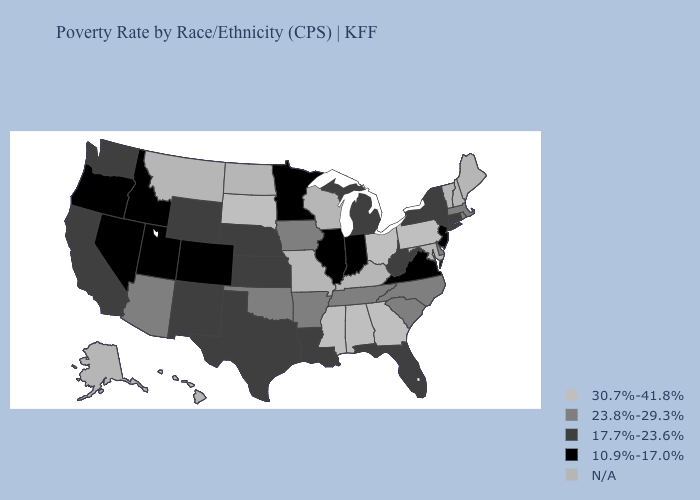Name the states that have a value in the range 23.8%-29.3%?
Short answer required. Arizona, Arkansas, Delaware, Iowa, Massachusetts, North Carolina, Oklahoma, Rhode Island, South Carolina, Tennessee. What is the value of Alabama?
Quick response, please. 30.7%-41.8%. Name the states that have a value in the range 30.7%-41.8%?
Keep it brief. Alabama, Georgia, Mississippi, Ohio, Pennsylvania, South Dakota. What is the value of Kentucky?
Short answer required. N/A. Does Pennsylvania have the highest value in the USA?
Be succinct. Yes. What is the highest value in states that border Arkansas?
Quick response, please. 30.7%-41.8%. Name the states that have a value in the range 17.7%-23.6%?
Quick response, please. California, Connecticut, Florida, Kansas, Louisiana, Michigan, Nebraska, New Mexico, New York, Texas, Washington, West Virginia, Wyoming. Which states have the highest value in the USA?
Give a very brief answer. Alabama, Georgia, Mississippi, Ohio, Pennsylvania, South Dakota. Name the states that have a value in the range N/A?
Be succinct. Alaska, Hawaii, Kentucky, Maine, Maryland, Missouri, Montana, New Hampshire, North Dakota, Vermont, Wisconsin. What is the value of Kansas?
Concise answer only. 17.7%-23.6%. What is the value of North Dakota?
Write a very short answer. N/A. Which states hav the highest value in the South?
Short answer required. Alabama, Georgia, Mississippi. 